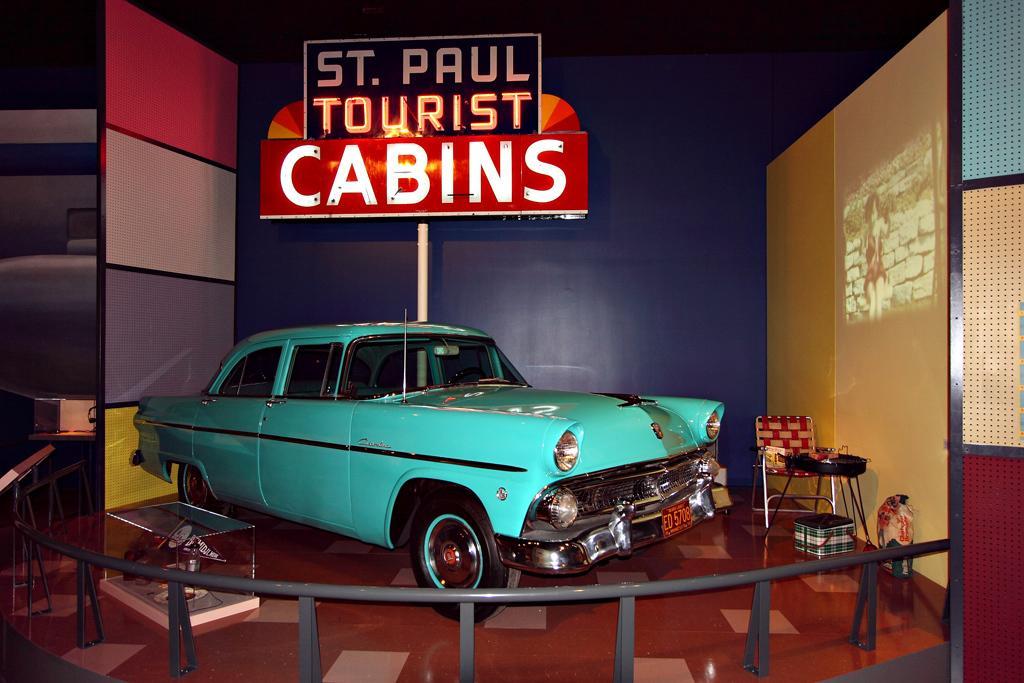Could you give a brief overview of what you see in this image? This is a cabin in which car is placed to show case the people. Behind the car there is a board named St Paul tourist cabins. On the right there is a chair and a small table. 